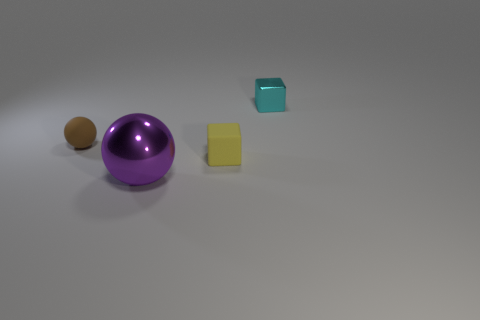How many brown matte objects are the same size as the shiny ball?
Keep it short and to the point. 0. What material is the cube right of the small yellow matte object right of the small rubber sphere?
Your response must be concise. Metal. The tiny rubber thing that is left of the metal thing that is on the left side of the tiny cyan cube that is behind the rubber ball is what shape?
Provide a short and direct response. Sphere. There is a object that is on the left side of the purple metal object; does it have the same shape as the tiny matte object to the right of the big purple metallic ball?
Offer a very short reply. No. What number of other objects are the same material as the yellow block?
Ensure brevity in your answer.  1. What is the shape of the small brown object that is the same material as the tiny yellow cube?
Ensure brevity in your answer.  Sphere. Does the purple shiny sphere have the same size as the rubber sphere?
Provide a succinct answer. No. What size is the metal thing to the right of the metallic sphere that is in front of the tiny metal block?
Provide a short and direct response. Small. How many balls are either small objects or matte objects?
Your answer should be compact. 1. Is the size of the cyan object the same as the block that is in front of the brown matte thing?
Your answer should be very brief. Yes. 